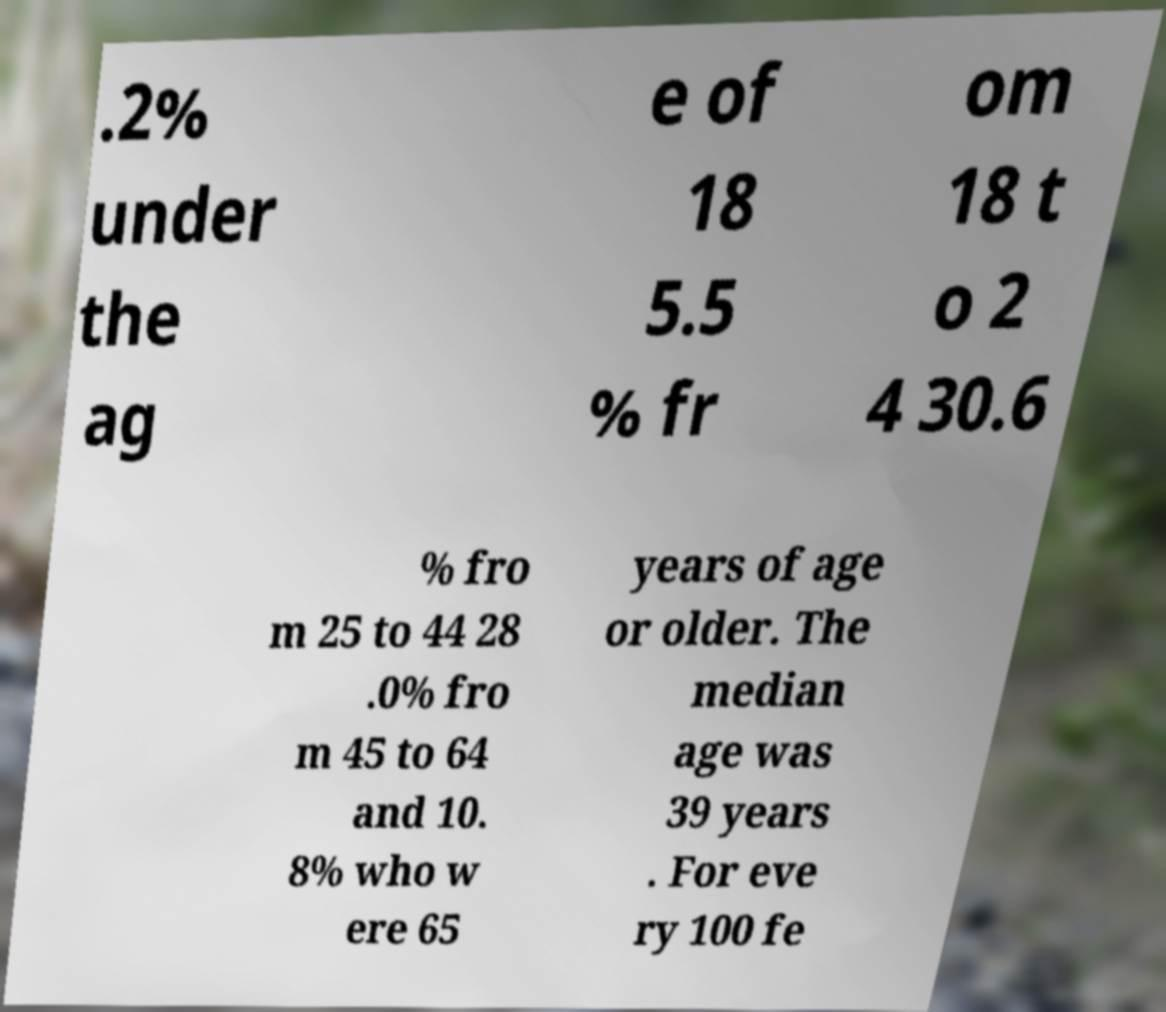What messages or text are displayed in this image? I need them in a readable, typed format. .2% under the ag e of 18 5.5 % fr om 18 t o 2 4 30.6 % fro m 25 to 44 28 .0% fro m 45 to 64 and 10. 8% who w ere 65 years of age or older. The median age was 39 years . For eve ry 100 fe 